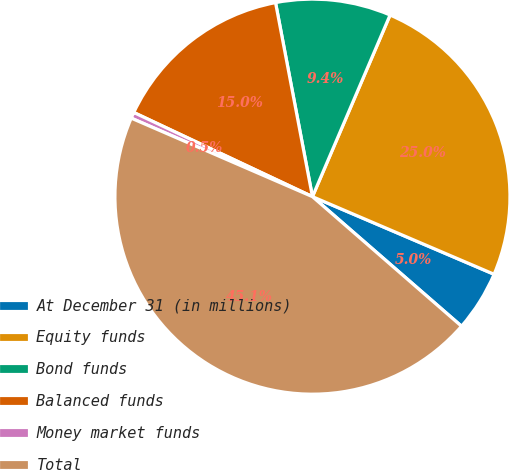Convert chart to OTSL. <chart><loc_0><loc_0><loc_500><loc_500><pie_chart><fcel>At December 31 (in millions)<fcel>Equity funds<fcel>Bond funds<fcel>Balanced funds<fcel>Money market funds<fcel>Total<nl><fcel>4.96%<fcel>25.0%<fcel>9.42%<fcel>15.0%<fcel>0.5%<fcel>45.12%<nl></chart> 